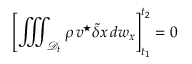Convert formula to latex. <formula><loc_0><loc_0><loc_500><loc_500>\left [ \iiint _ { { \mathcal { D } } _ { t } } \rho \, { \boldsymbol v } ^ { ^ { * } } \tilde { \delta } x \, d w _ { x } \right ] _ { t _ { 1 } } ^ { t _ { 2 } } = 0</formula> 